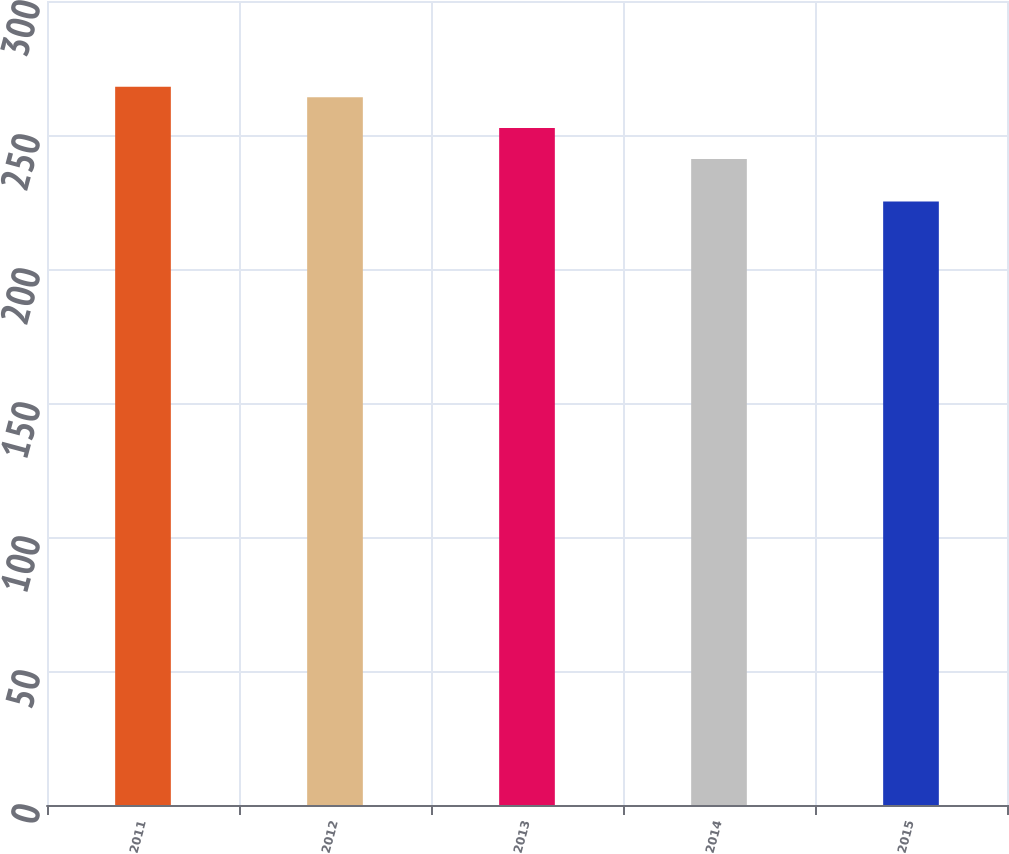Convert chart. <chart><loc_0><loc_0><loc_500><loc_500><bar_chart><fcel>2011<fcel>2012<fcel>2013<fcel>2014<fcel>2015<nl><fcel>268<fcel>264.1<fcel>252.6<fcel>241<fcel>225.2<nl></chart> 